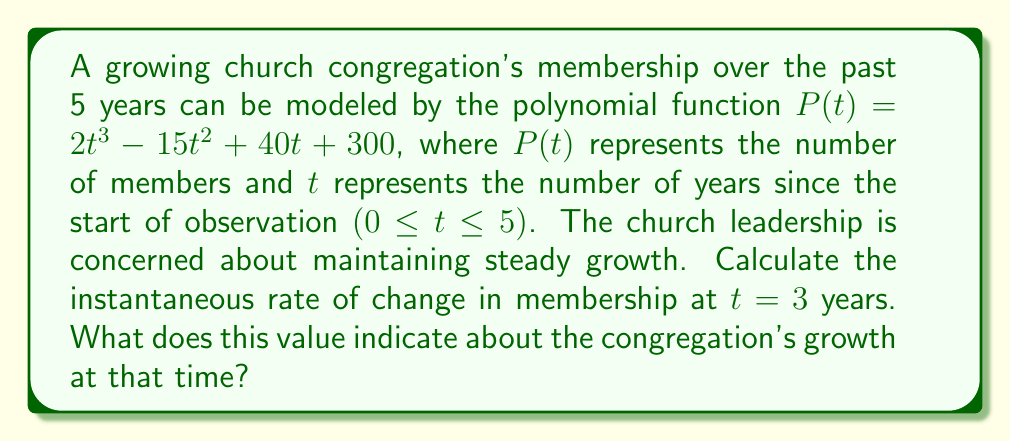Show me your answer to this math problem. To find the instantaneous rate of change at t = 3, we need to find the derivative of the function P(t) and evaluate it at t = 3.

1. Given function: $P(t) = 2t^3 - 15t^2 + 40t + 300$

2. Find the derivative P'(t):
   $P'(t) = 6t^2 - 30t + 40$

3. Evaluate P'(t) at t = 3:
   $P'(3) = 6(3)^2 - 30(3) + 40$
   $= 6(9) - 90 + 40$
   $= 54 - 90 + 40$
   $= 4$

The instantaneous rate of change at t = 3 is 4 members per year.

This positive value indicates that the congregation is still growing at t = 3, but at a relatively slow rate. The growth rate of 4 members per year suggests that while the church is still attracting new members, the rate of growth has slowed compared to earlier years. This information could be valuable for church leadership in assessing their outreach and retention strategies to maintain steady growth in alignment with their conservative values.
Answer: The instantaneous rate of change at t = 3 years is 4 members per year, indicating slow but positive growth in the congregation at that time. 